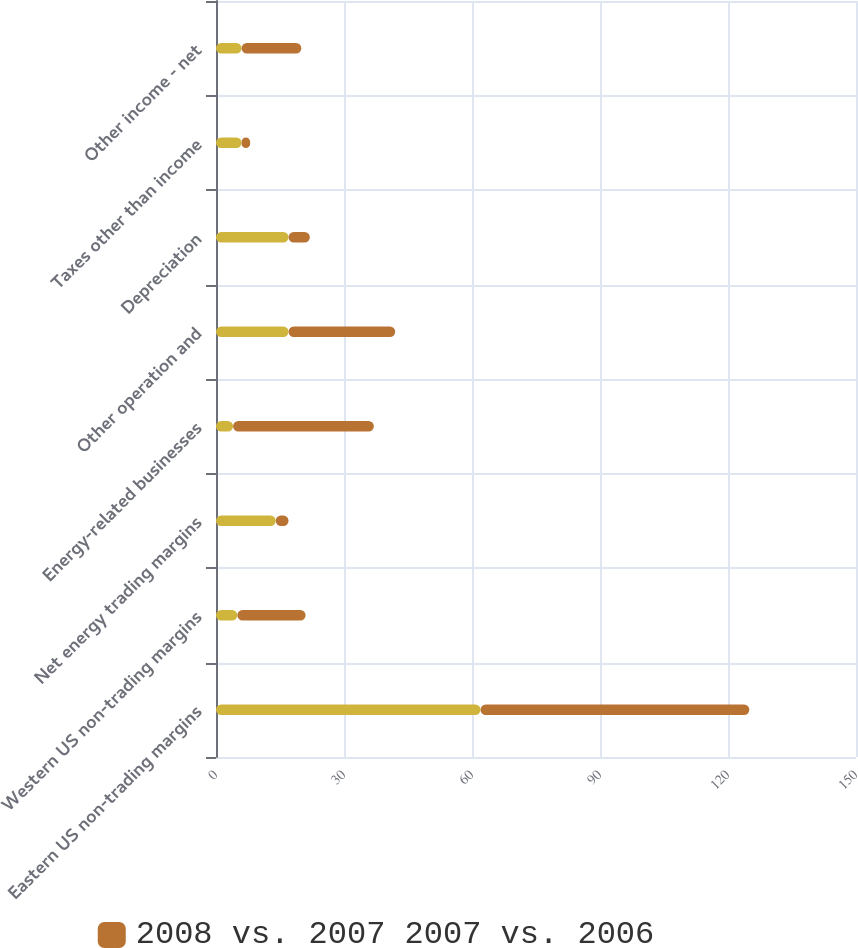<chart> <loc_0><loc_0><loc_500><loc_500><stacked_bar_chart><ecel><fcel>Eastern US non-trading margins<fcel>Western US non-trading margins<fcel>Net energy trading margins<fcel>Energy-related businesses<fcel>Other operation and<fcel>Depreciation<fcel>Taxes other than income<fcel>Other income - net<nl><fcel>nan<fcel>62<fcel>5<fcel>14<fcel>4<fcel>17<fcel>17<fcel>6<fcel>6<nl><fcel>2008 vs. 2007 2007 vs. 2006<fcel>63<fcel>16<fcel>3<fcel>33<fcel>25<fcel>5<fcel>2<fcel>14<nl></chart> 